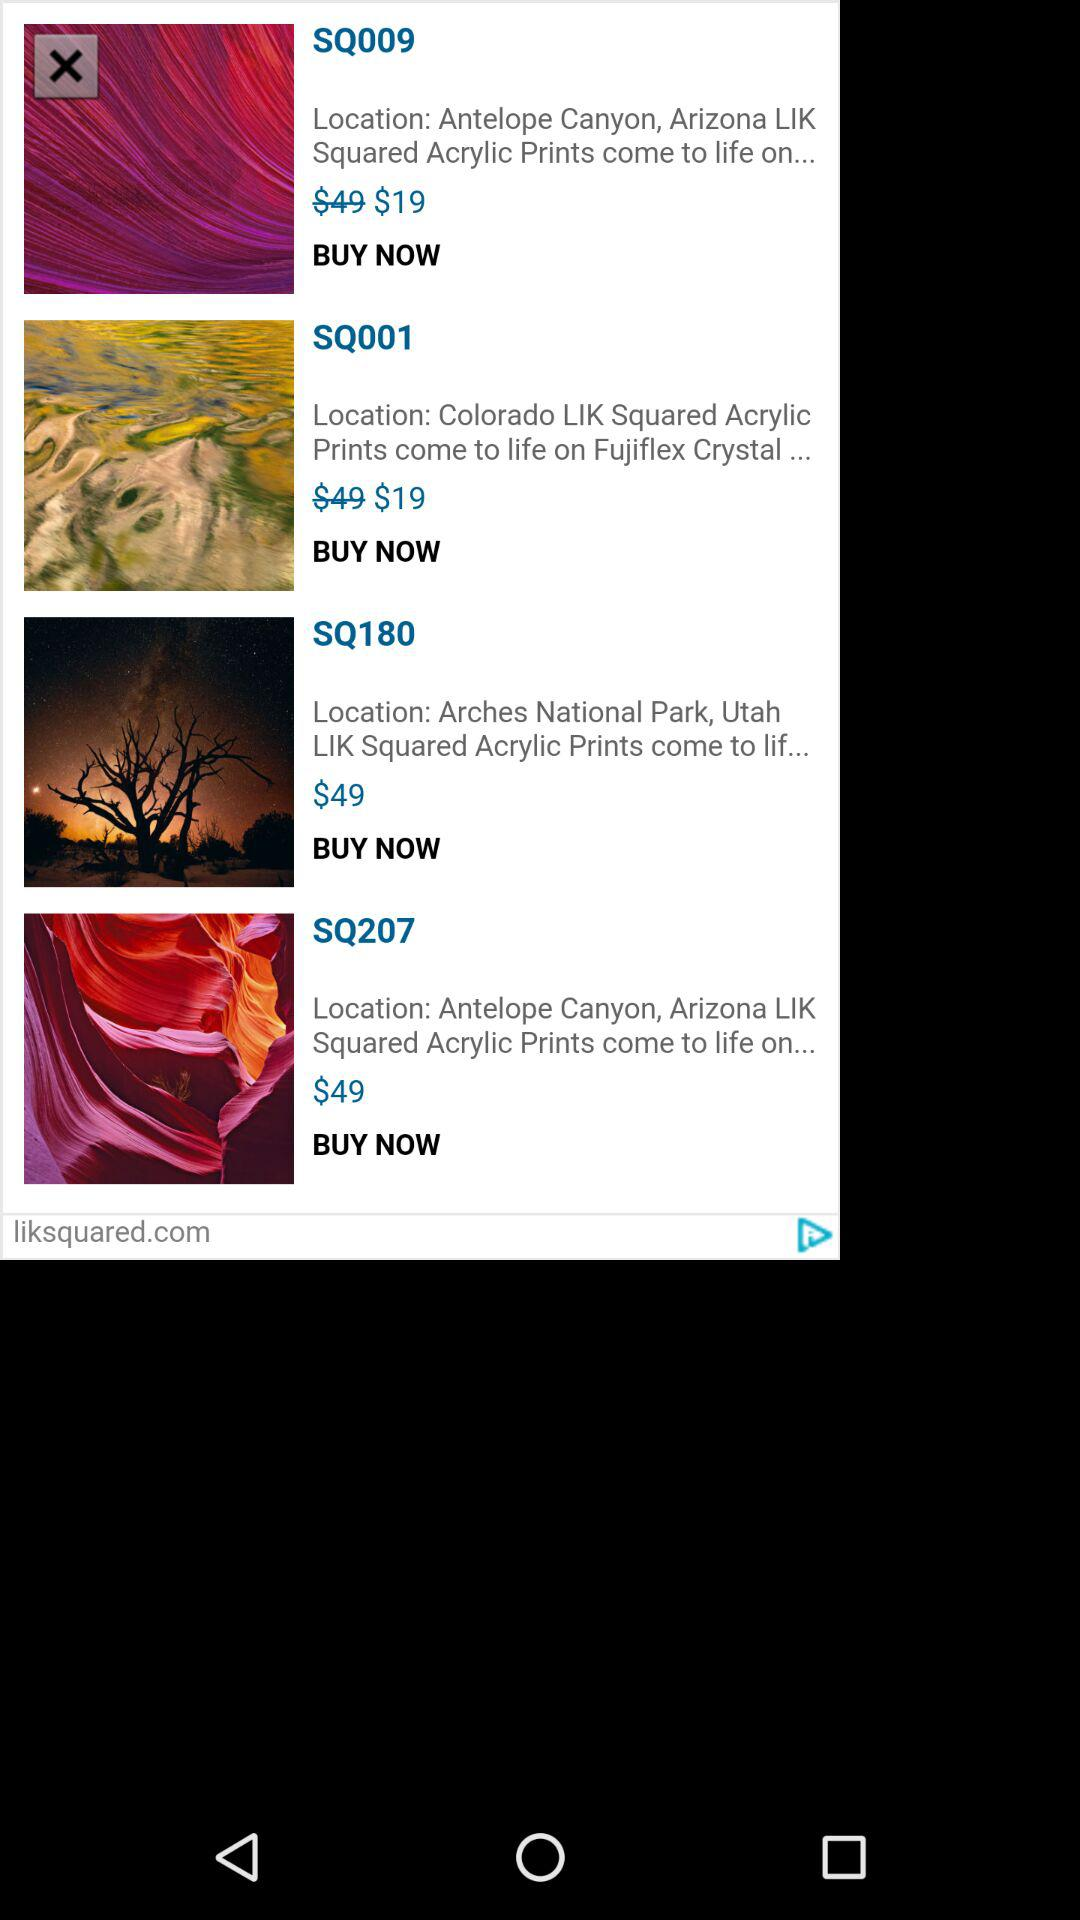What is the price of "SQ207"? The price is $49. 